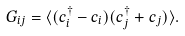Convert formula to latex. <formula><loc_0><loc_0><loc_500><loc_500>G _ { i j } = \langle ( c ^ { \dagger } _ { i } - c _ { i } ) ( c ^ { \dagger } _ { j } + c _ { j } ) \rangle .</formula> 